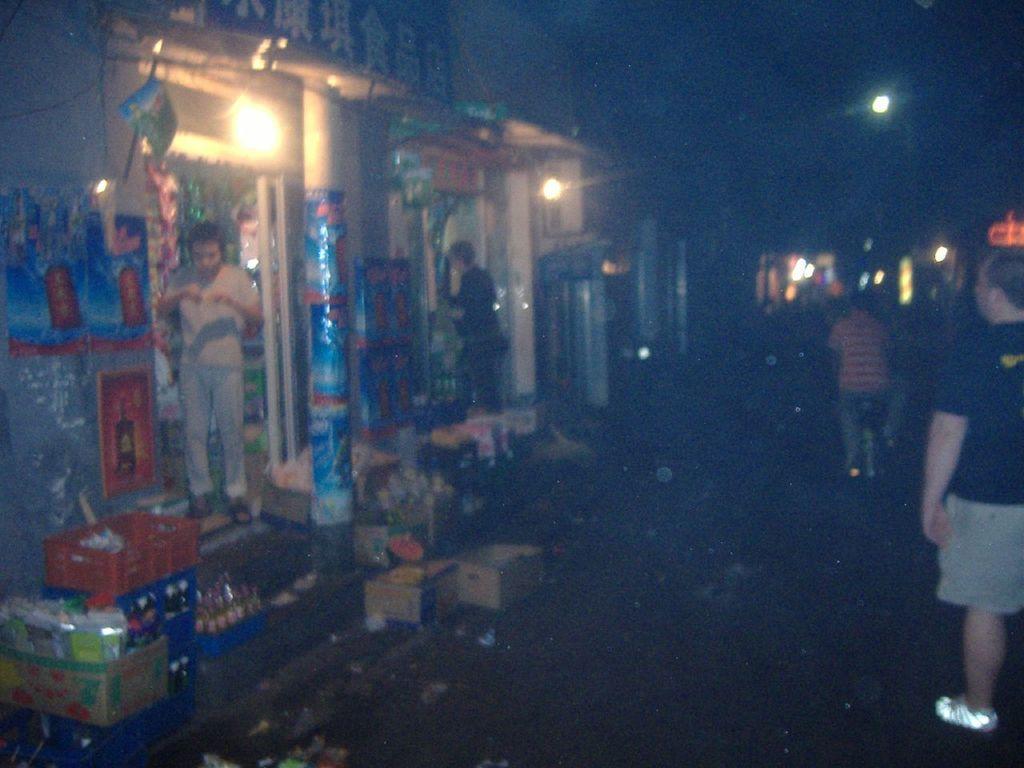In one or two sentences, can you explain what this image depicts? In this image, there are a few people. We can see the ground with some objects. We can also see some stories and baskets with objects. We can also see some pillars and the wall with some posters. We can see some lights. 